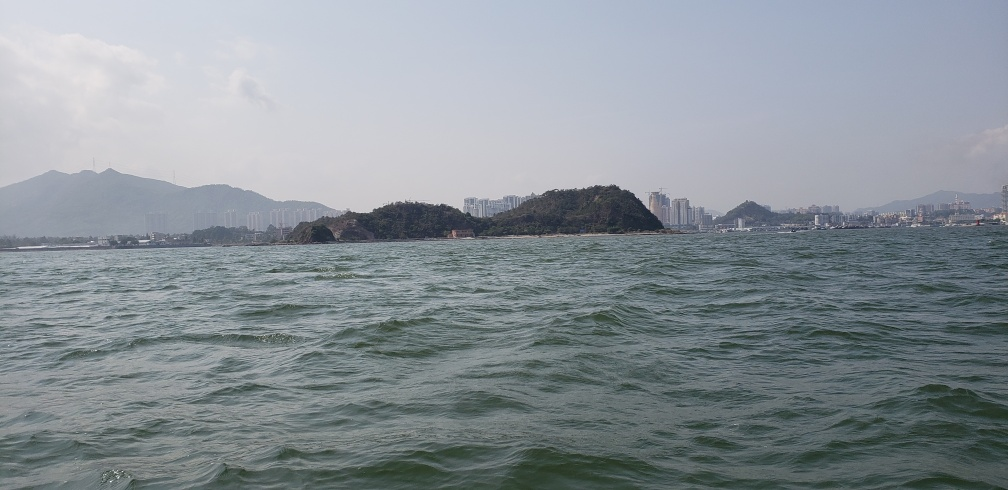Does the photo depict both turbulent waves and calmness?
 Yes 